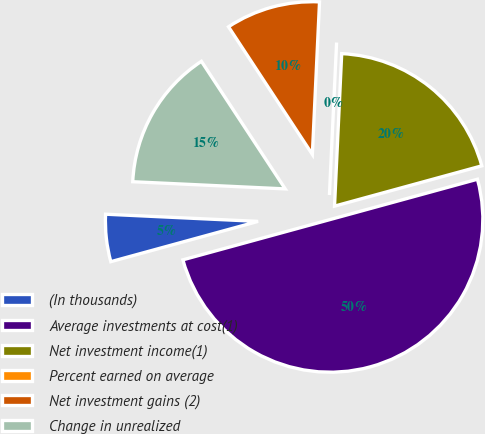Convert chart. <chart><loc_0><loc_0><loc_500><loc_500><pie_chart><fcel>(In thousands)<fcel>Average investments at cost(1)<fcel>Net investment income(1)<fcel>Percent earned on average<fcel>Net investment gains (2)<fcel>Change in unrealized<nl><fcel>5.0%<fcel>50.0%<fcel>20.0%<fcel>0.0%<fcel>10.0%<fcel>15.0%<nl></chart> 